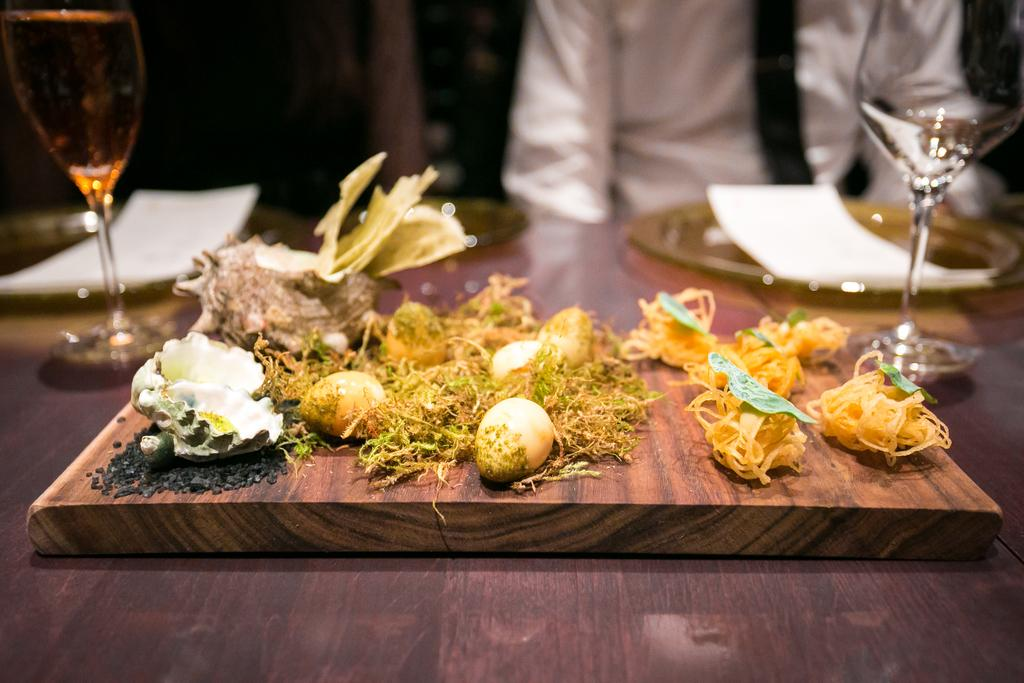What type of items can be seen on the table in the image? There are eatable items on the table. Can you describe any specific tableware in the image? There are two wine glasses on the table. What type of appliance is used to taste the food in the image? There is no appliance present in the image for tasting food; people typically use their taste buds to taste food. 